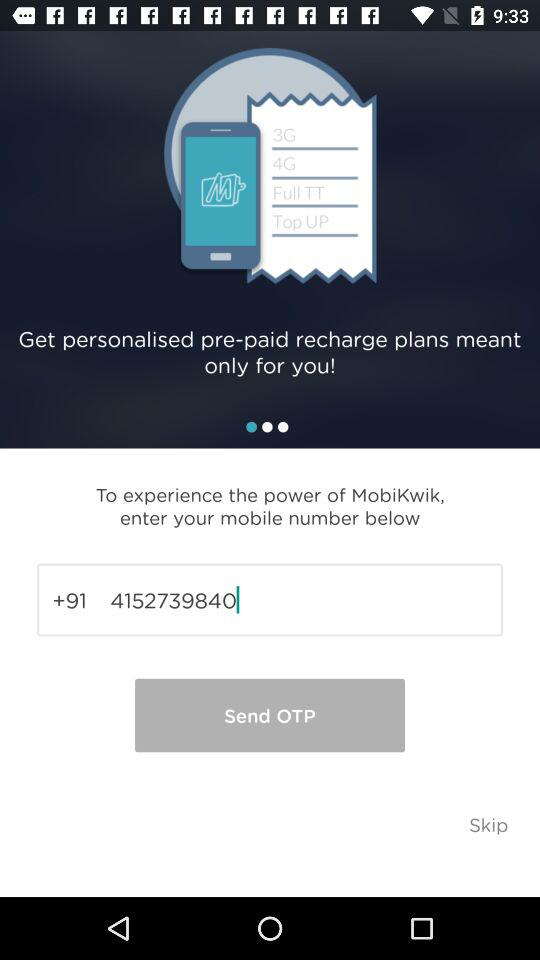What is the mobile number? The mobile number is +91 4152739840. 